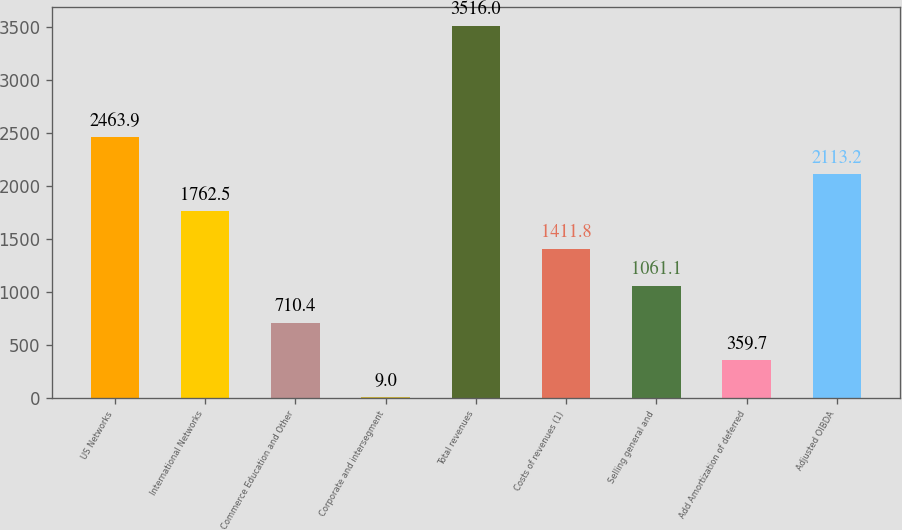Convert chart. <chart><loc_0><loc_0><loc_500><loc_500><bar_chart><fcel>US Networks<fcel>International Networks<fcel>Commerce Education and Other<fcel>Corporate and intersegment<fcel>Total revenues<fcel>Costs of revenues (1)<fcel>Selling general and<fcel>Add Amortization of deferred<fcel>Adjusted OIBDA<nl><fcel>2463.9<fcel>1762.5<fcel>710.4<fcel>9<fcel>3516<fcel>1411.8<fcel>1061.1<fcel>359.7<fcel>2113.2<nl></chart> 